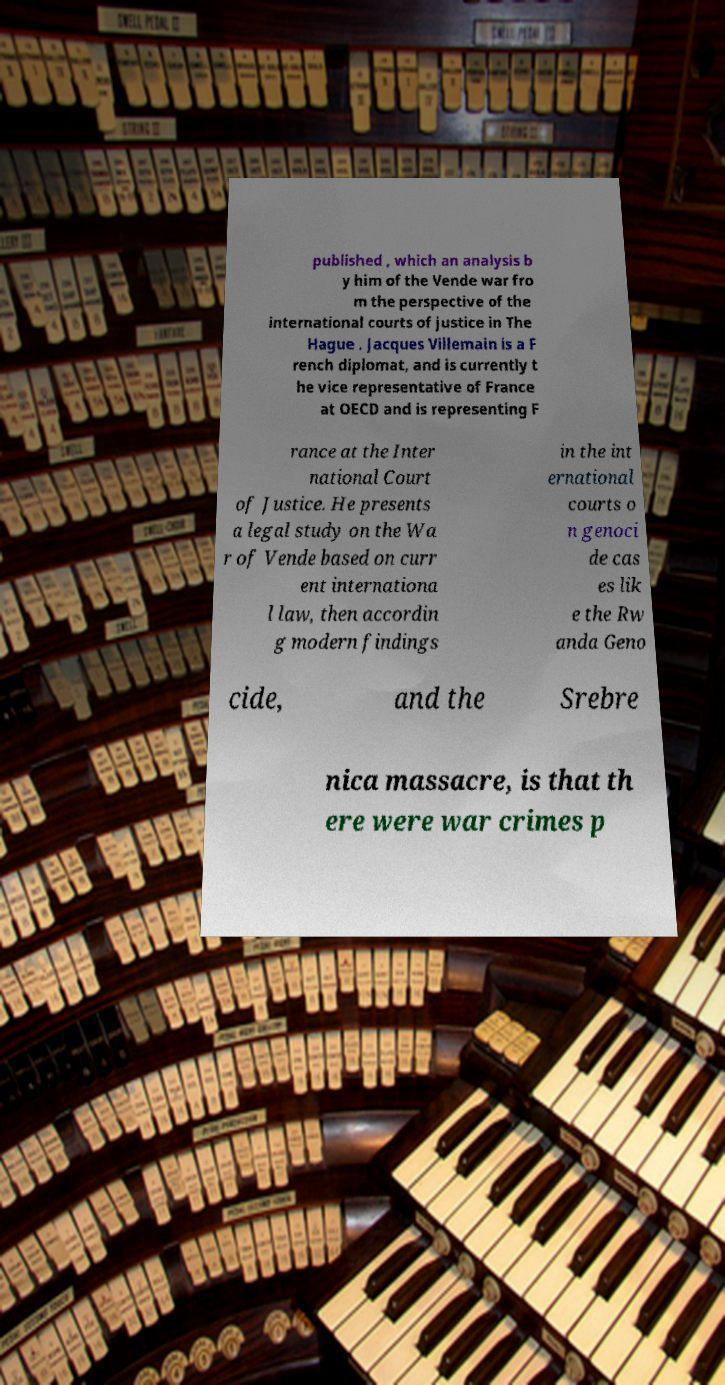For documentation purposes, I need the text within this image transcribed. Could you provide that? published , which an analysis b y him of the Vende war fro m the perspective of the international courts of justice in The Hague . Jacques Villemain is a F rench diplomat, and is currently t he vice representative of France at OECD and is representing F rance at the Inter national Court of Justice. He presents a legal study on the Wa r of Vende based on curr ent internationa l law, then accordin g modern findings in the int ernational courts o n genoci de cas es lik e the Rw anda Geno cide, and the Srebre nica massacre, is that th ere were war crimes p 